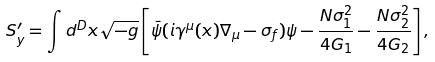<formula> <loc_0><loc_0><loc_500><loc_500>S _ { y } ^ { \prime } = \int d ^ { D } x \sqrt { - g } \left [ \bar { \psi } ( i \gamma ^ { \mu } ( x ) \nabla _ { \mu } - \sigma _ { f } ) \psi - \frac { N \sigma _ { 1 } ^ { 2 } } { 4 G _ { 1 } } - \frac { N \sigma _ { 2 } ^ { 2 } } { 4 G _ { 2 } } \right ] ,</formula> 